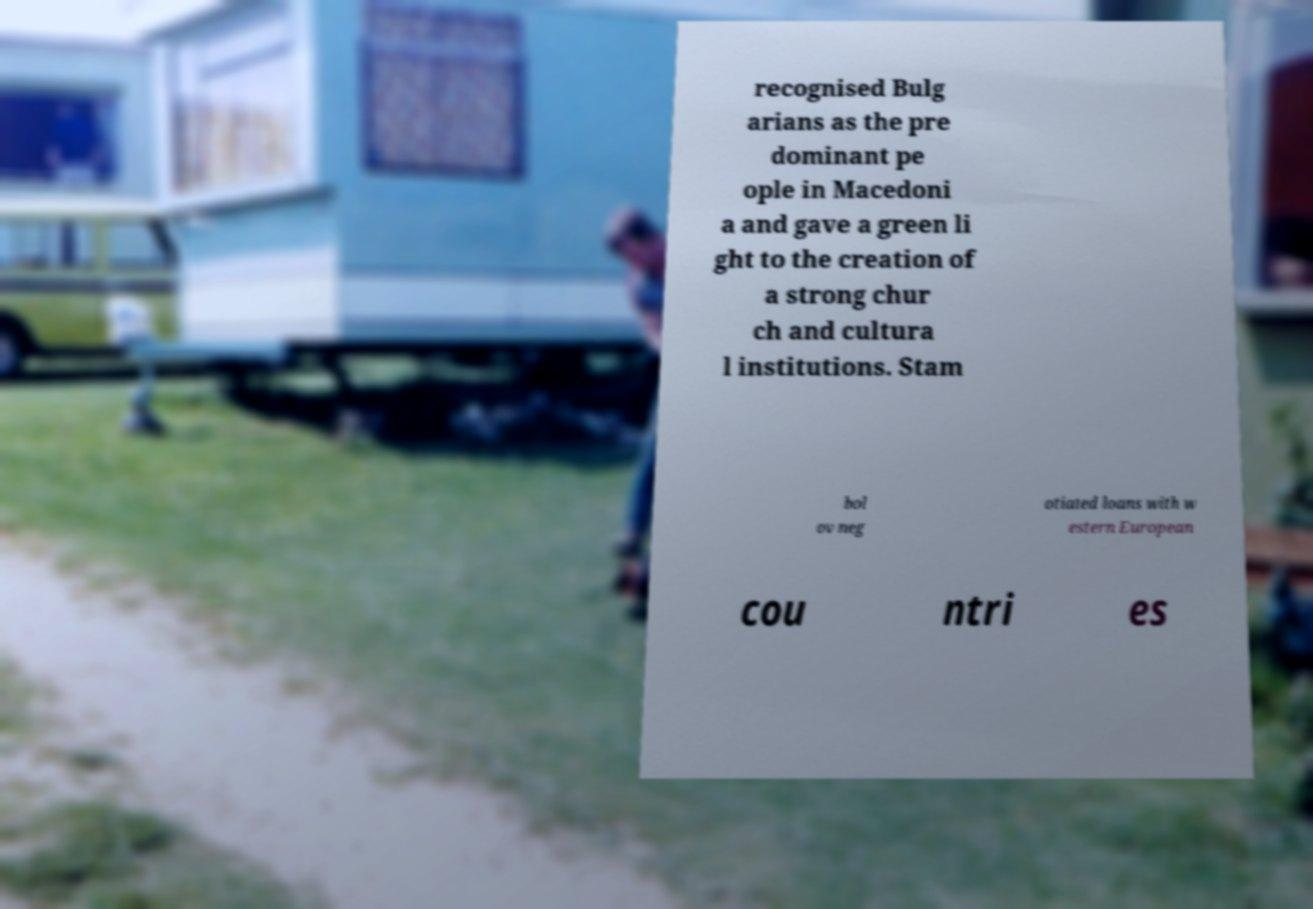What messages or text are displayed in this image? I need them in a readable, typed format. recognised Bulg arians as the pre dominant pe ople in Macedoni a and gave a green li ght to the creation of a strong chur ch and cultura l institutions. Stam bol ov neg otiated loans with w estern European cou ntri es 